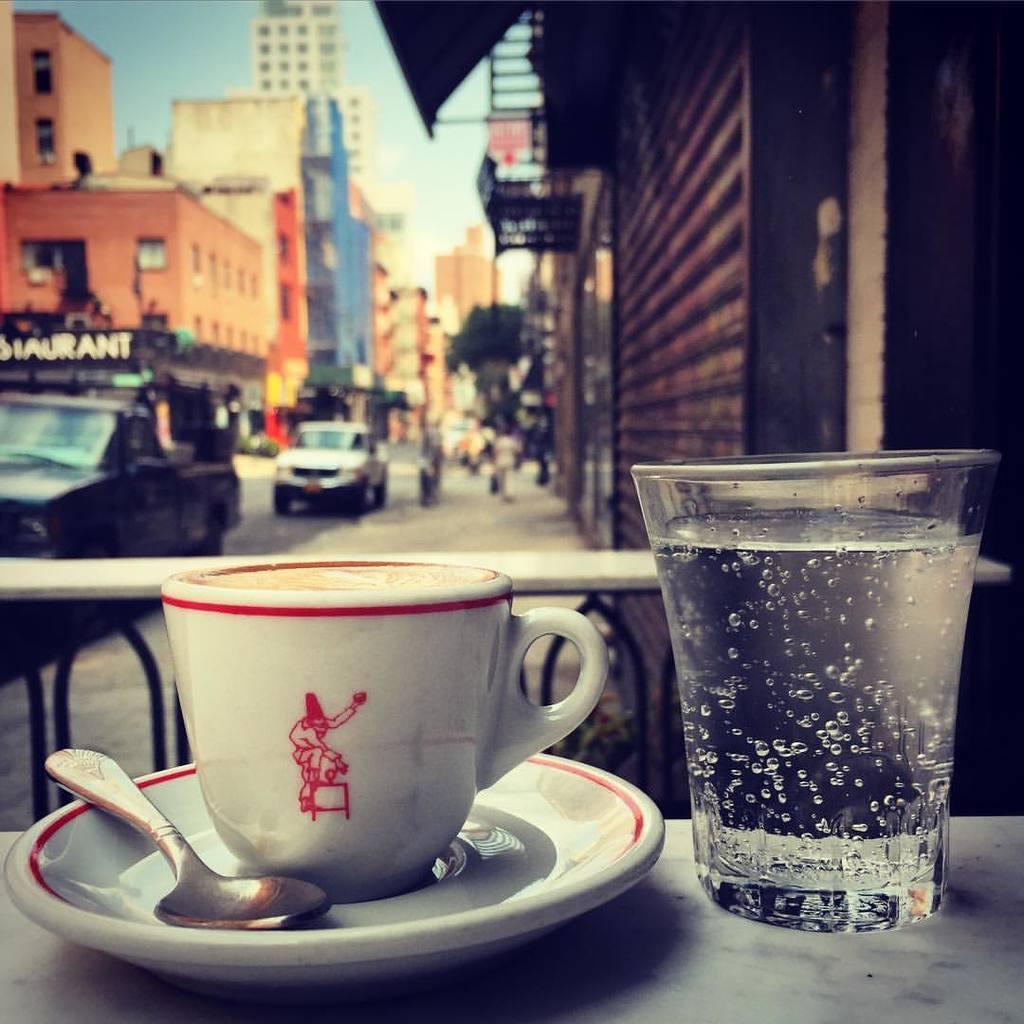What objects are present in the image related to serving or consuming a beverage? There is a cup and saucer, a spoon, and a glass in the image. On what surface are these objects placed? These objects are kept on a surface. What can be seen in the background of the image? There are vehicles, buildings, and the sky visible in the background of the image. How many stamps are on the cup in the image? There are no stamps present on the cup in the image. What type of dime is used to pay for the glass in the image? There is no mention of a dime or any form of payment in the image. 